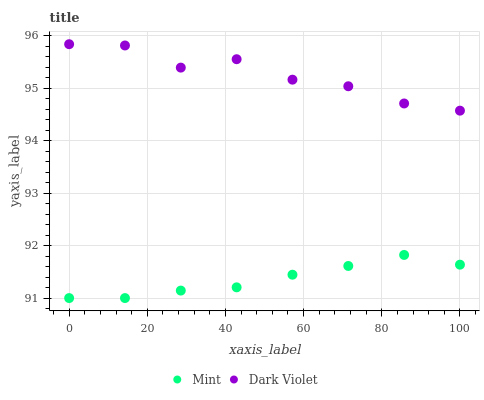Does Mint have the minimum area under the curve?
Answer yes or no. Yes. Does Dark Violet have the maximum area under the curve?
Answer yes or no. Yes. Does Dark Violet have the minimum area under the curve?
Answer yes or no. No. Is Mint the smoothest?
Answer yes or no. Yes. Is Dark Violet the roughest?
Answer yes or no. Yes. Is Dark Violet the smoothest?
Answer yes or no. No. Does Mint have the lowest value?
Answer yes or no. Yes. Does Dark Violet have the lowest value?
Answer yes or no. No. Does Dark Violet have the highest value?
Answer yes or no. Yes. Is Mint less than Dark Violet?
Answer yes or no. Yes. Is Dark Violet greater than Mint?
Answer yes or no. Yes. Does Mint intersect Dark Violet?
Answer yes or no. No. 